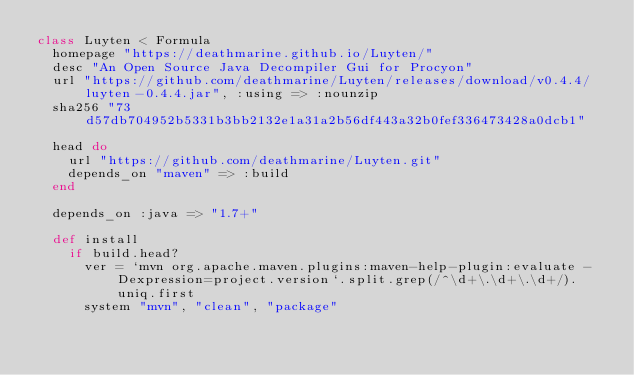<code> <loc_0><loc_0><loc_500><loc_500><_Ruby_>class Luyten < Formula
  homepage "https://deathmarine.github.io/Luyten/"
  desc "An Open Source Java Decompiler Gui for Procyon"
  url "https://github.com/deathmarine/Luyten/releases/download/v0.4.4/luyten-0.4.4.jar", :using => :nounzip
  sha256 "73d57db704952b5331b3bb2132e1a31a2b56df443a32b0fef336473428a0dcb1"

  head do
    url "https://github.com/deathmarine/Luyten.git"
    depends_on "maven" => :build
  end

  depends_on :java => "1.7+"

  def install
    if build.head?
      ver = `mvn org.apache.maven.plugins:maven-help-plugin:evaluate -Dexpression=project.version`.split.grep(/^\d+\.\d+\.\d+/).uniq.first
      system "mvn", "clean", "package"</code> 